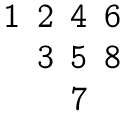Convert formula to latex. <formula><loc_0><loc_0><loc_500><loc_500>\begin{matrix} 1 & 2 & 4 & 6 \\ & 3 & 5 & 8 \\ & & 7 & \end{matrix}</formula> 